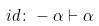Convert formula to latex. <formula><loc_0><loc_0><loc_500><loc_500>{ i d \colon - \alpha \vdash \alpha }</formula> 